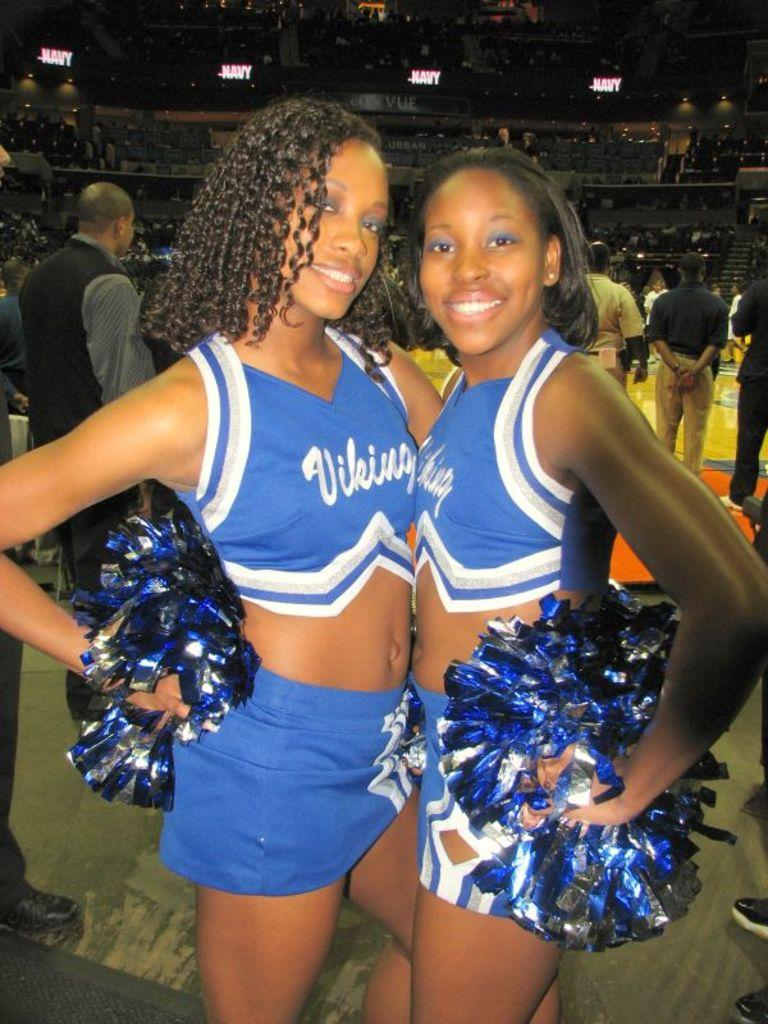Provide a one-sentence caption for the provided image. Vikings are the team that the girls are cheering for. 